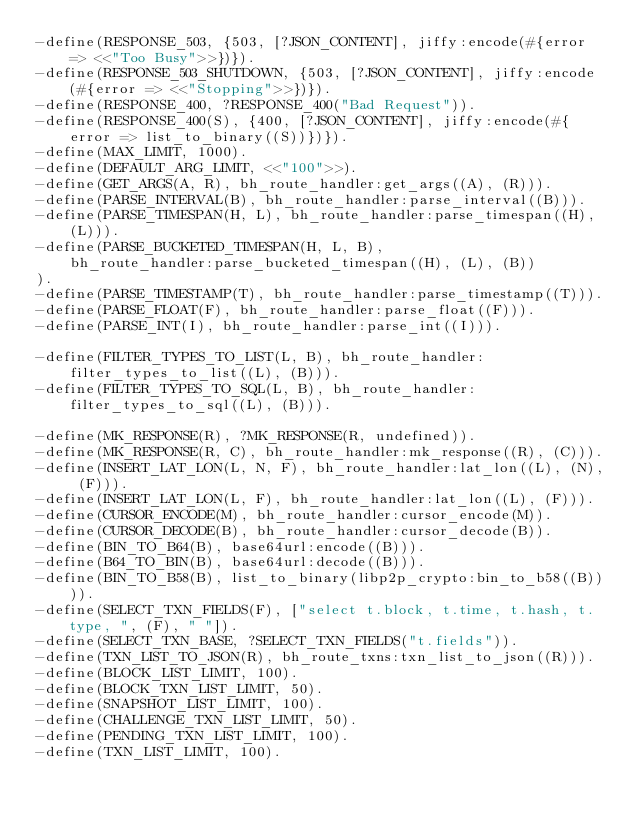<code> <loc_0><loc_0><loc_500><loc_500><_Erlang_>-define(RESPONSE_503, {503, [?JSON_CONTENT], jiffy:encode(#{error => <<"Too Busy">>})}).
-define(RESPONSE_503_SHUTDOWN, {503, [?JSON_CONTENT], jiffy:encode(#{error => <<"Stopping">>})}).
-define(RESPONSE_400, ?RESPONSE_400("Bad Request")).
-define(RESPONSE_400(S), {400, [?JSON_CONTENT], jiffy:encode(#{error => list_to_binary((S))})}).
-define(MAX_LIMIT, 1000).
-define(DEFAULT_ARG_LIMIT, <<"100">>).
-define(GET_ARGS(A, R), bh_route_handler:get_args((A), (R))).
-define(PARSE_INTERVAL(B), bh_route_handler:parse_interval((B))).
-define(PARSE_TIMESPAN(H, L), bh_route_handler:parse_timespan((H), (L))).
-define(PARSE_BUCKETED_TIMESPAN(H, L, B),
    bh_route_handler:parse_bucketed_timespan((H), (L), (B))
).
-define(PARSE_TIMESTAMP(T), bh_route_handler:parse_timestamp((T))).
-define(PARSE_FLOAT(F), bh_route_handler:parse_float((F))).
-define(PARSE_INT(I), bh_route_handler:parse_int((I))).

-define(FILTER_TYPES_TO_LIST(L, B), bh_route_handler:filter_types_to_list((L), (B))).
-define(FILTER_TYPES_TO_SQL(L, B), bh_route_handler:filter_types_to_sql((L), (B))).

-define(MK_RESPONSE(R), ?MK_RESPONSE(R, undefined)).
-define(MK_RESPONSE(R, C), bh_route_handler:mk_response((R), (C))).
-define(INSERT_LAT_LON(L, N, F), bh_route_handler:lat_lon((L), (N), (F))).
-define(INSERT_LAT_LON(L, F), bh_route_handler:lat_lon((L), (F))).
-define(CURSOR_ENCODE(M), bh_route_handler:cursor_encode(M)).
-define(CURSOR_DECODE(B), bh_route_handler:cursor_decode(B)).
-define(BIN_TO_B64(B), base64url:encode((B))).
-define(B64_TO_BIN(B), base64url:decode((B))).
-define(BIN_TO_B58(B), list_to_binary(libp2p_crypto:bin_to_b58((B)))).
-define(SELECT_TXN_FIELDS(F), ["select t.block, t.time, t.hash, t.type, ", (F), " "]).
-define(SELECT_TXN_BASE, ?SELECT_TXN_FIELDS("t.fields")).
-define(TXN_LIST_TO_JSON(R), bh_route_txns:txn_list_to_json((R))).
-define(BLOCK_LIST_LIMIT, 100).
-define(BLOCK_TXN_LIST_LIMIT, 50).
-define(SNAPSHOT_LIST_LIMIT, 100).
-define(CHALLENGE_TXN_LIST_LIMIT, 50).
-define(PENDING_TXN_LIST_LIMIT, 100).
-define(TXN_LIST_LIMIT, 100).
</code> 